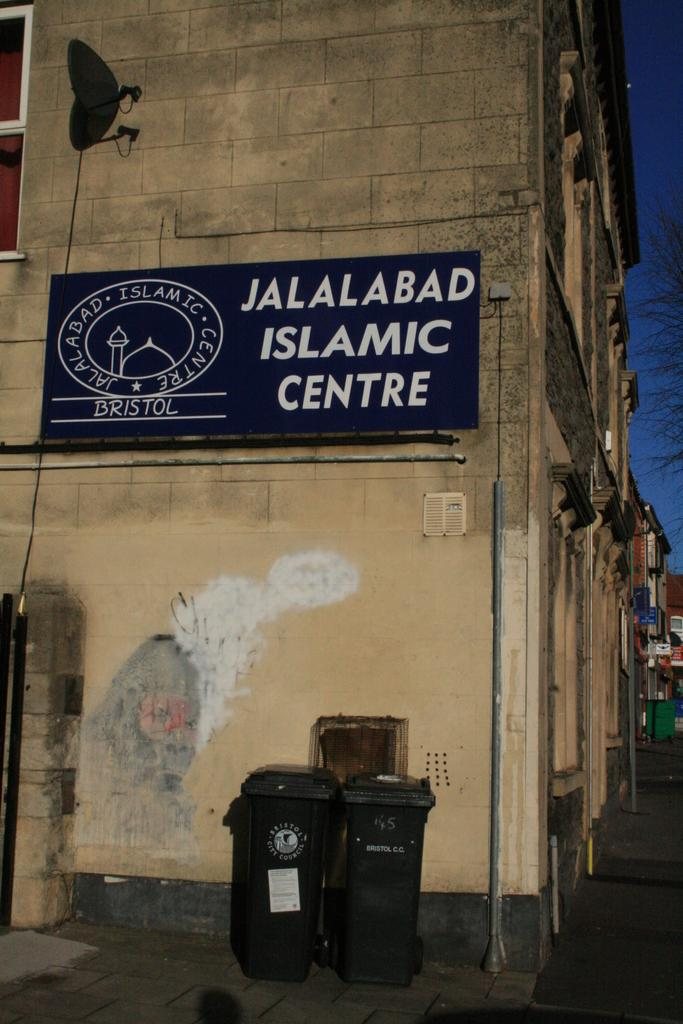Provide a one-sentence caption for the provided image. Blue sign which says "Jalalabad Islamic Centre" on a building. 